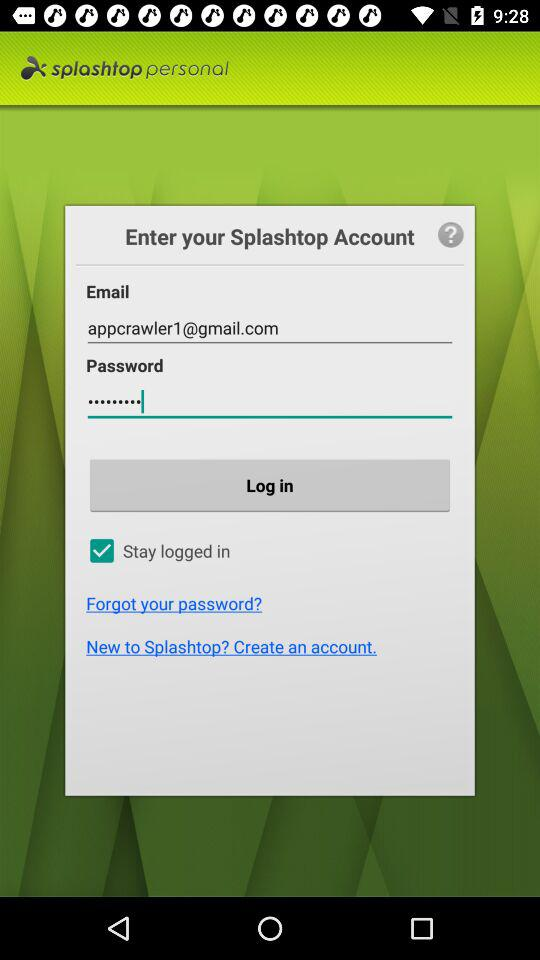What's the Google Mail address used by the user to log in? The Google Mail address used by the user is appcrawler1@gmail.com. 